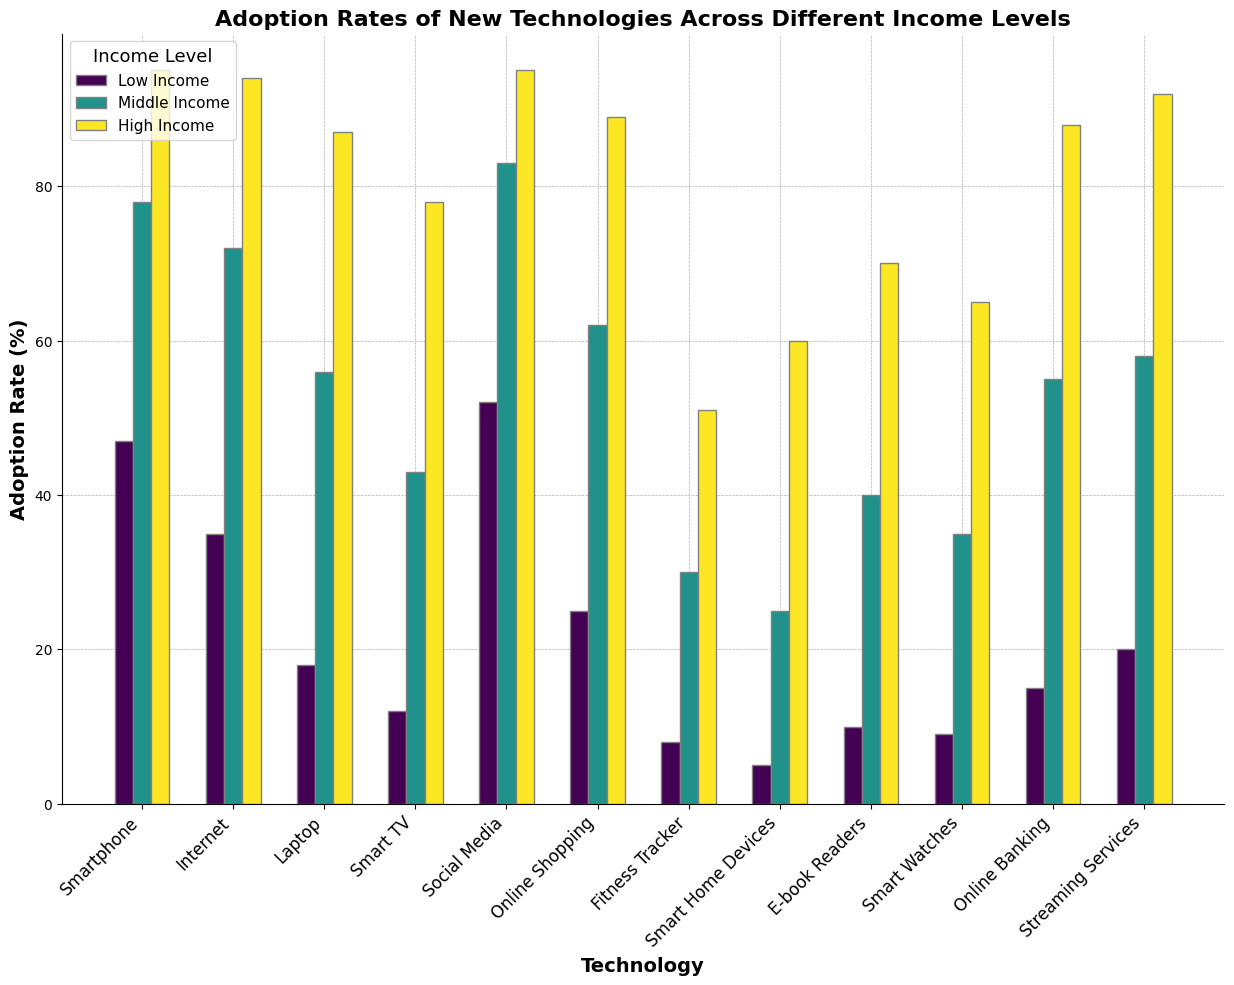What's the adoption rate of the Internet for low-income and high-income groups combined? To find the combined adoption rate for low-income and high-income groups, add their respective adoption rates for the Internet. Low-income adoption rate is 35% and high-income adoption rate is 94%. Thus, the combined rate is 35% + 94% = 129%.
Answer: 129% How does the adoption rate of smartphones differ between middle-income and low-income groups? To determine the difference, subtract the adoption rate of smartphones for the low-income group from the middle-income group. Middle-income adoption rate is 78% and low-income adoption rate is 47%. The difference is 78% - 47% = 31%.
Answer: 31% Which income group has the highest adoption rate for fitness trackers? Looking at the visual representation, the adoption rates of fitness trackers for different income levels are clearly marked. High-income groups have the highest adoption rate of 51%.
Answer: High income Does the adoption rate of smart home devices for middle-income groups exceed 20%? Referencing the figure, the adoption rate of smart home devices for middle-income groups is visually confirmed as 25%, which indeed exceeds 20%.
Answer: Yes What is the average adoption rate of online banking across all three income levels? To calculate the average, sum the adoption rates for online banking across low, middle, and high-income groups and divide by the number of groups. The rates are 15%, 55%, and 88%. The sum is 15% + 55% + 88% = 158%, and the average is 158% / 3 = 52.67%.
Answer: 52.67% How much greater is the adoption rate of streaming services in the high-income group compared to the low-income group? Compute the difference by subtracting the adoption rate of streaming services in the low-income group from that in the high-income group. High-income adoption rate is 92%, and low-income is 20%. The difference is 92% - 20% = 72%.
Answer: 72% Is the adoption rate for e-book readers in the high-income group double that of the middle-income group? To verify this claim, compare the adoption rates directly. The high-income group has an adoption rate of 70%, and the middle-income group has 40%. Doubling 40% (which gives 80%) is not equal to 70%.
Answer: No Is it true that all high-income groups have adoption rates above 50% for all technologies? Verify each technology's adoption rate for high-income groups. All rates are indeed greater than 50%.
Answer: Yes 